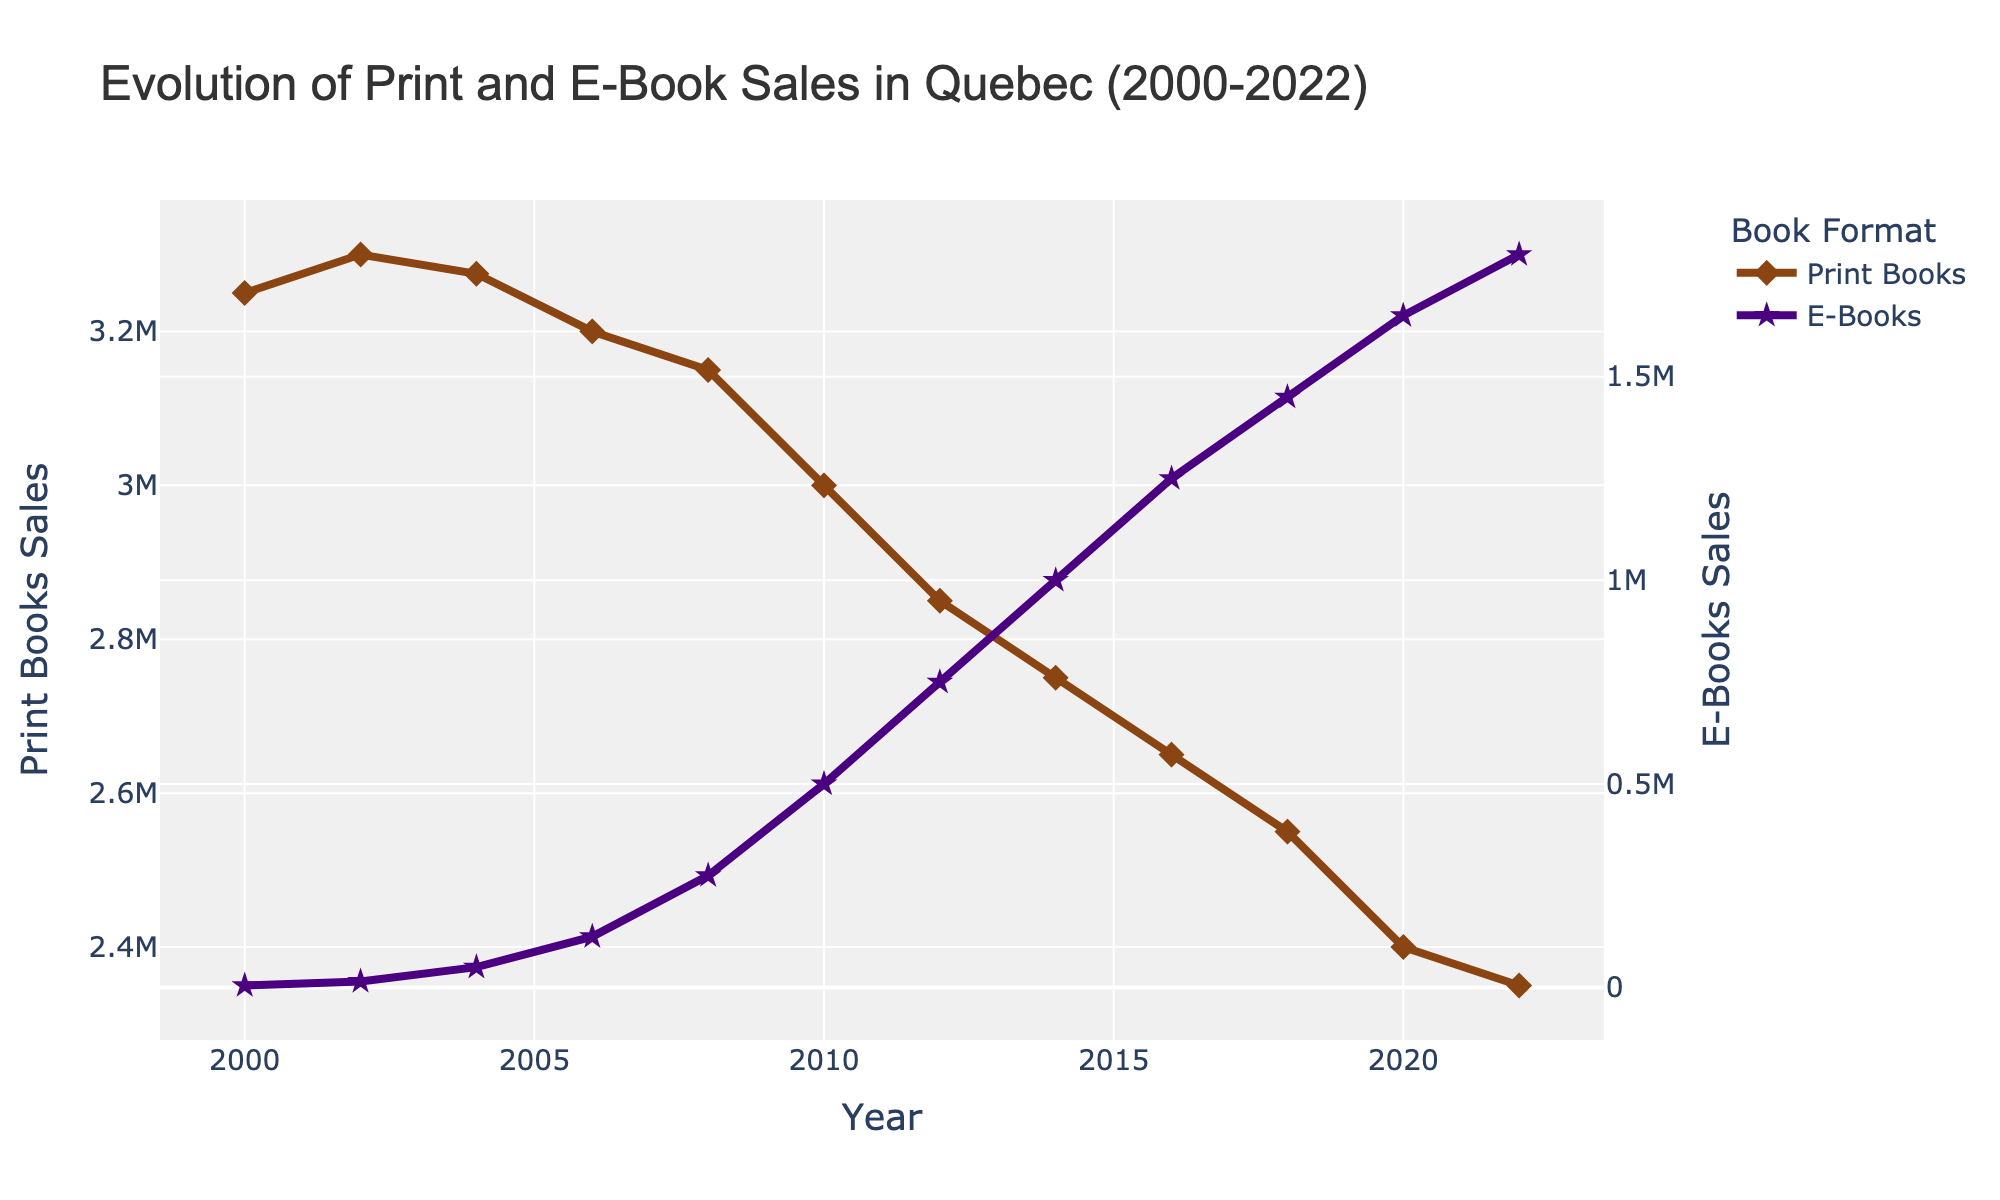What is the trend in print book sales from 2000 to 2022? The sales of print books show a declining trend from 2000 to 2022. Initially, the sales were 3,250,000 in 2000, and they reduced to 2,350,000 by 2022.
Answer: Declining How much did e-book sales increase between 2000 and 2022? The e-book sales increased from 5,000 in 2000 to 1,800,000 in 2022. Subtracting these values gives the increase: 1,800,000 - 5,000 = 1,795,000.
Answer: 1,795,000 In which year did total book sales reach 4,000,000? Looking at the total sales data, total book sales reached 4,000,000 in 2018.
Answer: 2018 Compare the sales of print and e-books in 2010. Which was higher and by how much? In 2010, print book sales were 3,000,000 and e-book sales were 500,000. The difference is 3,000,000 - 500,000 = 2,500,000. Print book sales were higher by 2,500,000.
Answer: Print books, by 2,500,000 What is the average annual sales of print books between 2000 and 2022? The total sales of print books over these years is 3,250,000 + 3,300,000 + 3,275,000 + 3,200,000 + 3,150,000 + 3,000,000 + 2,850,000 + 2,750,000 + 2,650,000 + 2,550,000 + 2,400,000 + 2,350,000 = 34,475,000. Dividing by the number of years (12): 34,475,000 / 12 = 2,872,917.
Answer: 2,872,917 Which format had the steepest growth rate, and in which period did it occur? The e-book format had the steepest growth rate with a significant increase from 275,000 in 2008 to 500,000 in 2010. This is 500,000 - 275,000 = 225,000, an increase over 2 years.
Answer: E-Books, 2008-2010 In 2020, what was the combined total sales from both formats? In 2020, print book sales were 2,400,000 and e-book sales were 1,650,000. Summing these gives 2,400,000 + 1,650,000 = 4,050,000.
Answer: 4,050,000 Between 2004 and 2014, how much did the sales of e-books increase? E-book sales in 2004 were 50,000 and in 2014 were 1,000,000. The increase is 1,000,000 - 50,000 = 950,000.
Answer: 950,000 What is the difference in total book sales between 2000 and 2022? The total book sales in 2000 were 3,255,000 and in 2022 were 4,150,000. The difference is 4,150,000 - 3,255,000 = 895,000.
Answer: 895,000 